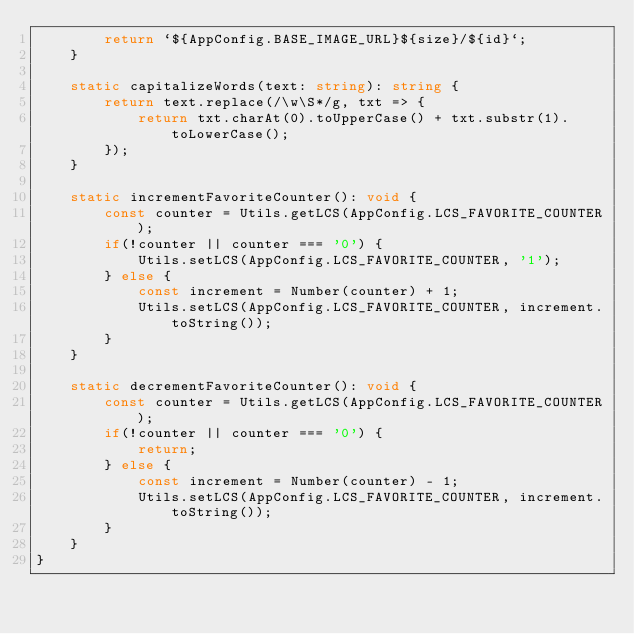Convert code to text. <code><loc_0><loc_0><loc_500><loc_500><_TypeScript_>        return `${AppConfig.BASE_IMAGE_URL}${size}/${id}`;
    }

    static capitalizeWords(text: string): string {
        return text.replace(/\w\S*/g, txt => {
            return txt.charAt(0).toUpperCase() + txt.substr(1).toLowerCase();
        });
    }

    static incrementFavoriteCounter(): void {
        const counter = Utils.getLCS(AppConfig.LCS_FAVORITE_COUNTER);
        if(!counter || counter === '0') {
            Utils.setLCS(AppConfig.LCS_FAVORITE_COUNTER, '1');
        } else {
            const increment = Number(counter) + 1;
            Utils.setLCS(AppConfig.LCS_FAVORITE_COUNTER, increment.toString());
        }
    }

    static decrementFavoriteCounter(): void {
        const counter = Utils.getLCS(AppConfig.LCS_FAVORITE_COUNTER);
        if(!counter || counter === '0') {
            return;
        } else {
            const increment = Number(counter) - 1;
            Utils.setLCS(AppConfig.LCS_FAVORITE_COUNTER, increment.toString());
        }
    }
}</code> 